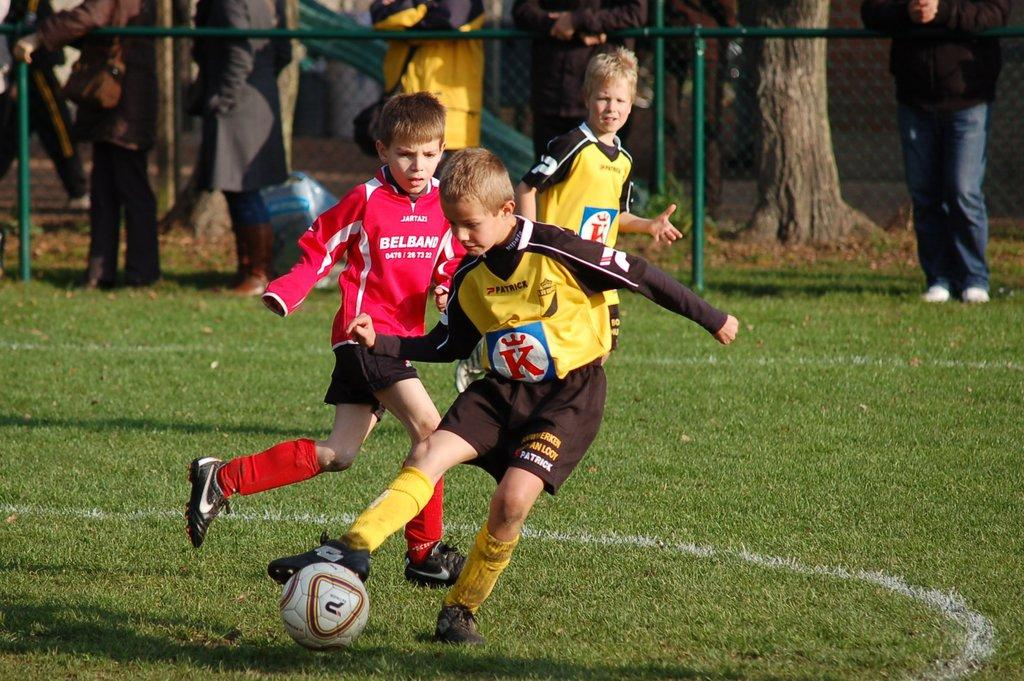What are the 3 people in the image doing? The 3 people in the image are playing football. What can be seen in the background of the image? In the background, there is a fence, a pole, trees, and a few people. Can you describe the setting of the image? The image is set in an outdoor area with a football field, surrounded by a fence and trees. What type of root is growing near the pole in the image? There is no root visible in the image; the focus is on the people playing football and the background elements. 